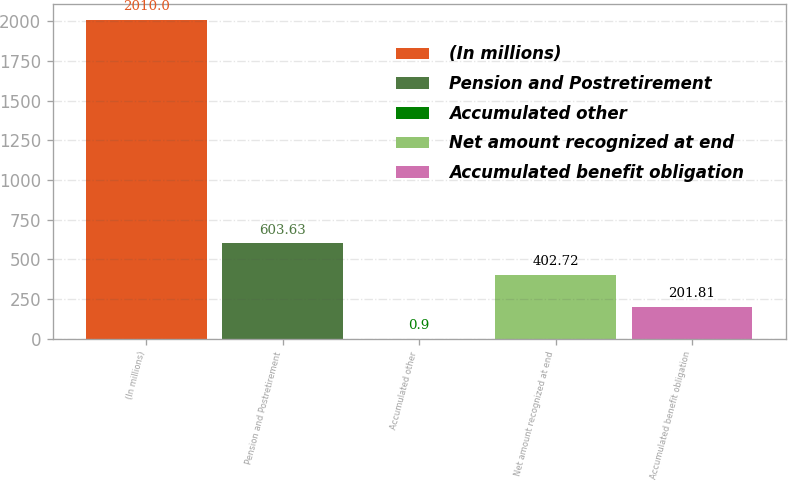Convert chart to OTSL. <chart><loc_0><loc_0><loc_500><loc_500><bar_chart><fcel>(In millions)<fcel>Pension and Postretirement<fcel>Accumulated other<fcel>Net amount recognized at end<fcel>Accumulated benefit obligation<nl><fcel>2010<fcel>603.63<fcel>0.9<fcel>402.72<fcel>201.81<nl></chart> 